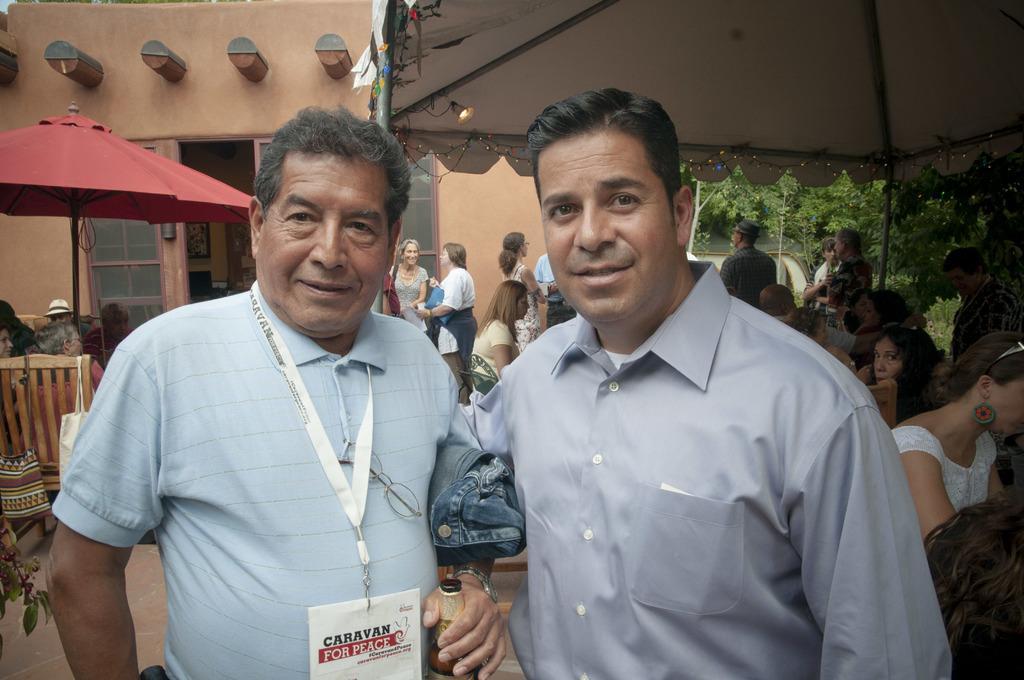Could you give a brief overview of what you see in this image? In this image, we can see two men smiling. We can see a man holding a cloth and bottle. In the background, we can see the people, poles, umbrella, tent, house, wall, glass objects, plants, path, light, decorative objects, few things. Few people are sitting on the chairs. 